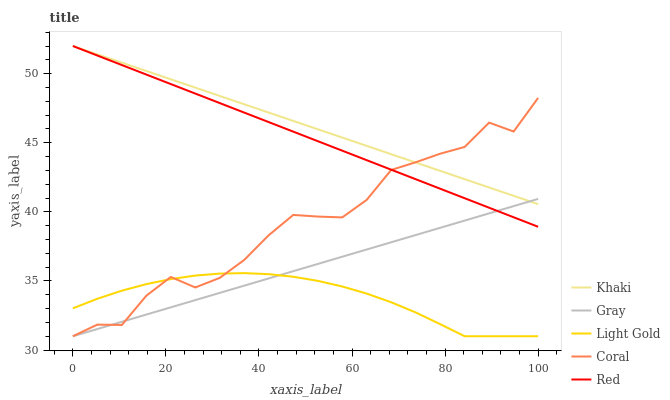Does Coral have the minimum area under the curve?
Answer yes or no. No. Does Coral have the maximum area under the curve?
Answer yes or no. No. Is Khaki the smoothest?
Answer yes or no. No. Is Khaki the roughest?
Answer yes or no. No. Does Khaki have the lowest value?
Answer yes or no. No. Does Coral have the highest value?
Answer yes or no. No. Is Light Gold less than Red?
Answer yes or no. Yes. Is Red greater than Light Gold?
Answer yes or no. Yes. Does Light Gold intersect Red?
Answer yes or no. No. 